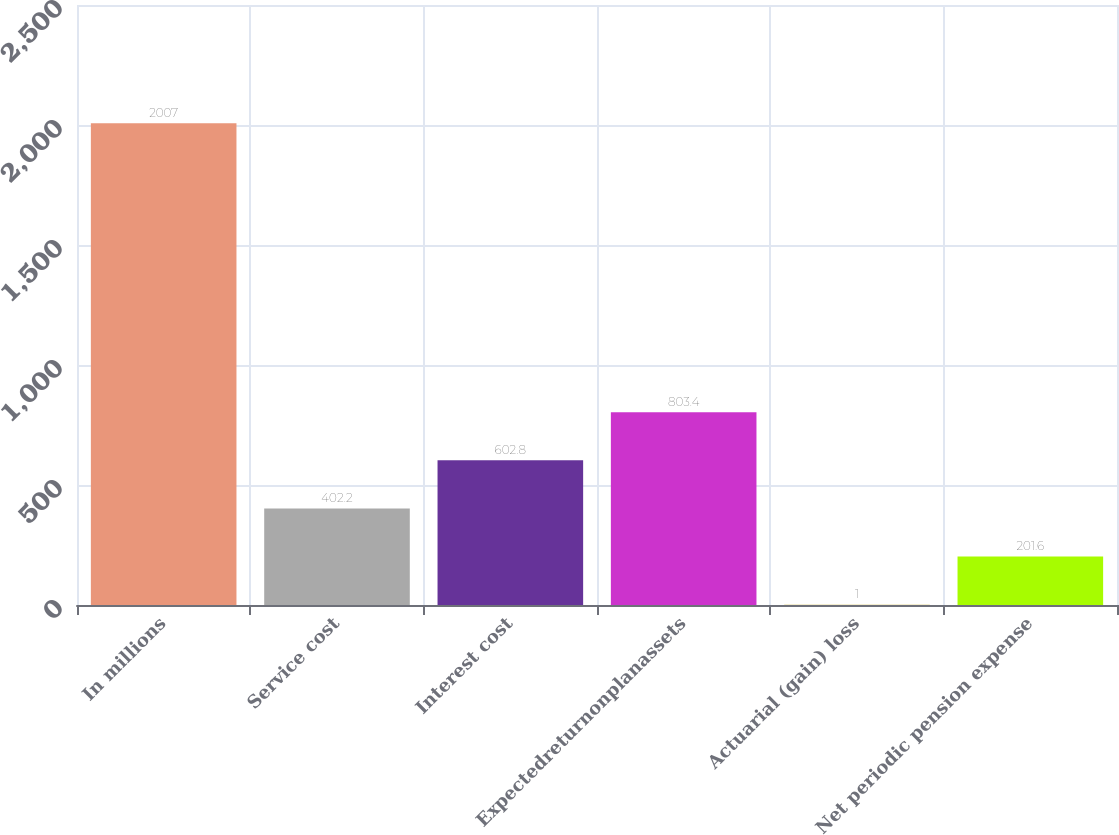Convert chart to OTSL. <chart><loc_0><loc_0><loc_500><loc_500><bar_chart><fcel>In millions<fcel>Service cost<fcel>Interest cost<fcel>Expectedreturnonplanassets<fcel>Actuarial (gain) loss<fcel>Net periodic pension expense<nl><fcel>2007<fcel>402.2<fcel>602.8<fcel>803.4<fcel>1<fcel>201.6<nl></chart> 